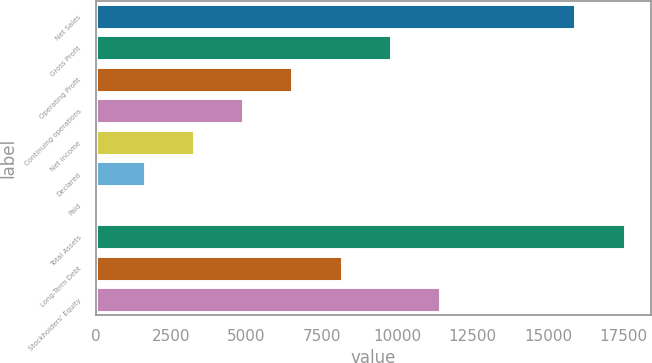Convert chart to OTSL. <chart><loc_0><loc_0><loc_500><loc_500><bar_chart><fcel>Net Sales<fcel>Gross Profit<fcel>Operating Profit<fcel>Continuing operations<fcel>Net income<fcel>Declared<fcel>Paid<fcel>Total Assets<fcel>Long-Term Debt<fcel>Stockholders' Equity<nl><fcel>15902.6<fcel>9782.65<fcel>6522.35<fcel>4892.2<fcel>3262.05<fcel>1631.9<fcel>1.75<fcel>17532.7<fcel>8152.5<fcel>11412.8<nl></chart> 